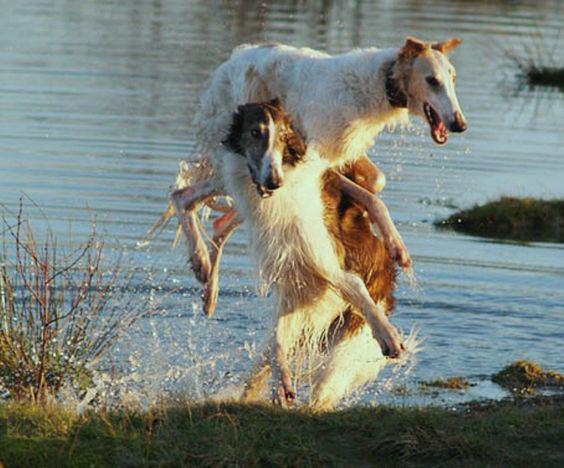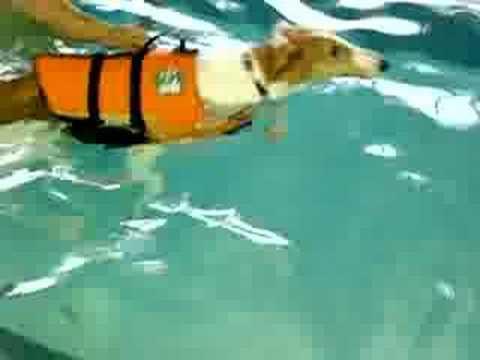The first image is the image on the left, the second image is the image on the right. For the images shown, is this caption "A single dog is in the water in the image on the right." true? Answer yes or no. Yes. The first image is the image on the left, the second image is the image on the right. Considering the images on both sides, is "In the image on the left a dog is leaping into the air by the water." valid? Answer yes or no. Yes. 